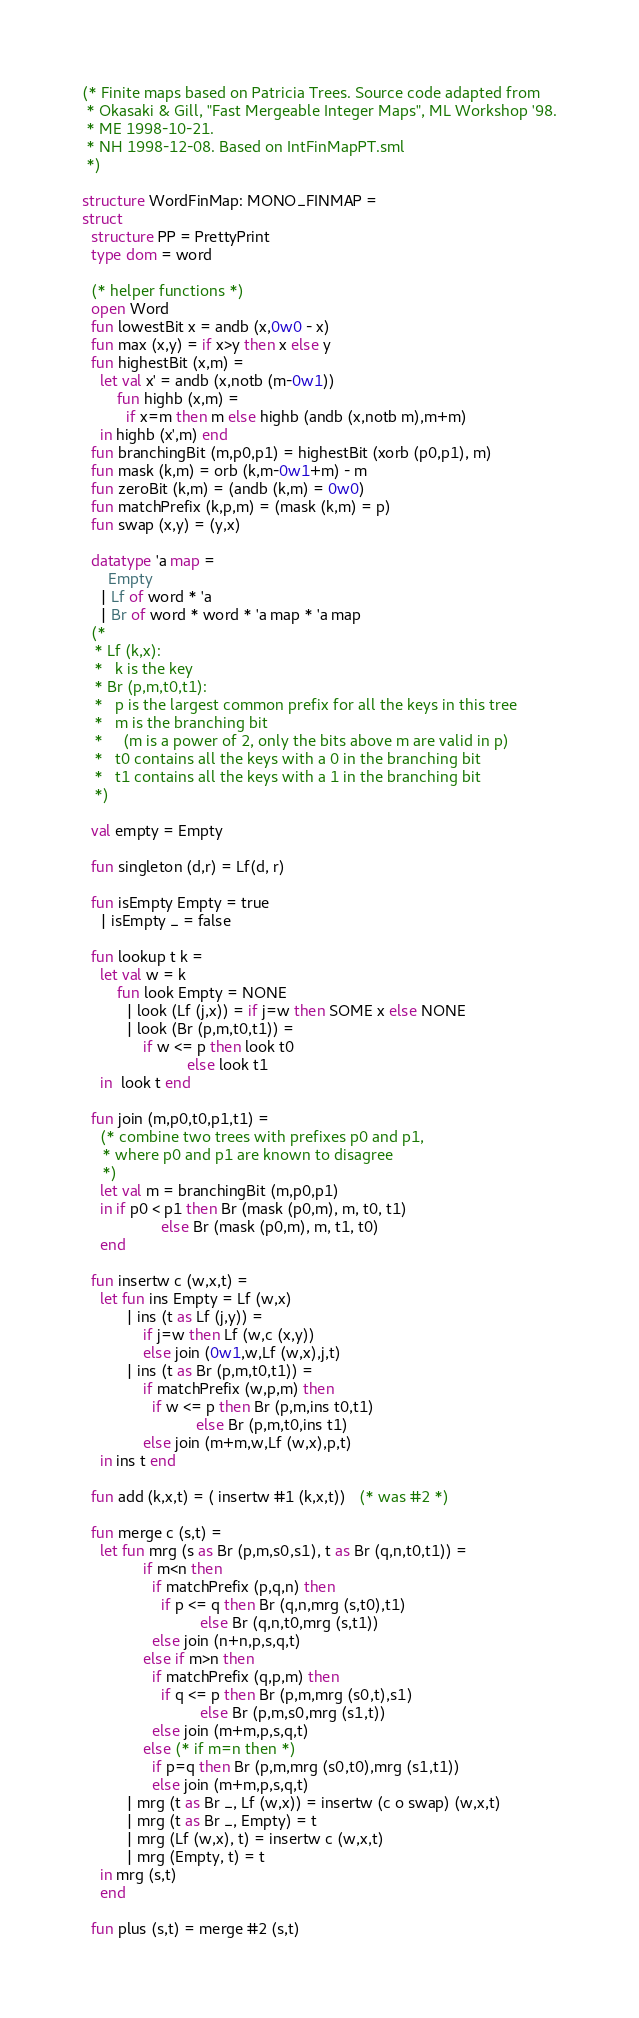Convert code to text. <code><loc_0><loc_0><loc_500><loc_500><_SML_>(* Finite maps based on Patricia Trees. Source code adapted from
 * Okasaki & Gill, "Fast Mergeable Integer Maps", ML Workshop '98.
 * ME 1998-10-21.
 * NH 1998-12-08. Based on IntFinMapPT.sml
 *)

structure WordFinMap: MONO_FINMAP =
struct
  structure PP = PrettyPrint
  type dom = word
  
  (* helper functions *)
  open Word
  fun lowestBit x = andb (x,0w0 - x)
  fun max (x,y) = if x>y then x else y
  fun highestBit (x,m) =
    let val x' = andb (x,notb (m-0w1))
        fun highb (x,m) =
          if x=m then m else highb (andb (x,notb m),m+m)
    in highb (x',m) end
  fun branchingBit (m,p0,p1) = highestBit (xorb (p0,p1), m)
  fun mask (k,m) = orb (k,m-0w1+m) - m
  fun zeroBit (k,m) = (andb (k,m) = 0w0)
  fun matchPrefix (k,p,m) = (mask (k,m) = p)
  fun swap (x,y) = (y,x)

  datatype 'a map =
      Empty
    | Lf of word * 'a
    | Br of word * word * 'a map * 'a map
  (* 
   * Lf (k,x): 
   *   k is the key 
   * Br (p,m,t0,t1):
   *   p is the largest common prefix for all the keys in this tree
   *   m is the branching bit
   *     (m is a power of 2, only the bits above m are valid in p)
   *   t0 contains all the keys with a 0 in the branching bit
   *   t1 contains all the keys with a 1 in the branching bit
   *)

  val empty = Empty

  fun singleton (d,r) = Lf(d, r)

  fun isEmpty Empty = true
    | isEmpty _ = false

  fun lookup t k =
    let val w = k
        fun look Empty = NONE
          | look (Lf (j,x)) = if j=w then SOME x else NONE
          | look (Br (p,m,t0,t1)) =
              if w <= p then look t0
                        else look t1
    in  look t end

  fun join (m,p0,t0,p1,t1) =
    (* combine two trees with prefixes p0 and p1,
     * where p0 and p1 are known to disagree
     *)
    let val m = branchingBit (m,p0,p1)
    in if p0 < p1 then Br (mask (p0,m), m, t0, t1)
                  else Br (mask (p0,m), m, t1, t0)
    end

  fun insertw c (w,x,t) =
    let fun ins Empty = Lf (w,x)
          | ins (t as Lf (j,y)) =
              if j=w then Lf (w,c (x,y))
              else join (0w1,w,Lf (w,x),j,t)
          | ins (t as Br (p,m,t0,t1)) =
              if matchPrefix (w,p,m) then
                if w <= p then Br (p,m,ins t0,t1)
                          else Br (p,m,t0,ins t1)
              else join (m+m,w,Lf (w,x),p,t)
    in ins t end

  fun add (k,x,t) = ( insertw #1 (k,x,t))   (* was #2 *)

  fun merge c (s,t) =
    let fun mrg (s as Br (p,m,s0,s1), t as Br (q,n,t0,t1)) =
              if m<n then
                if matchPrefix (p,q,n) then
                  if p <= q then Br (q,n,mrg (s,t0),t1)
                           else Br (q,n,t0,mrg (s,t1))
                else join (n+n,p,s,q,t)
              else if m>n then
                if matchPrefix (q,p,m) then
                  if q <= p then Br (p,m,mrg (s0,t),s1)
                           else Br (p,m,s0,mrg (s1,t))
                else join (m+m,p,s,q,t)
              else (* if m=n then *)
                if p=q then Br (p,m,mrg (s0,t0),mrg (s1,t1))
                else join (m+m,p,s,q,t)
          | mrg (t as Br _, Lf (w,x)) = insertw (c o swap) (w,x,t)
          | mrg (t as Br _, Empty) = t
          | mrg (Lf (w,x), t) = insertw c (w,x,t)
          | mrg (Empty, t) = t
    in mrg (s,t)
    end

  fun plus (s,t) = merge #2 (s,t)
</code> 